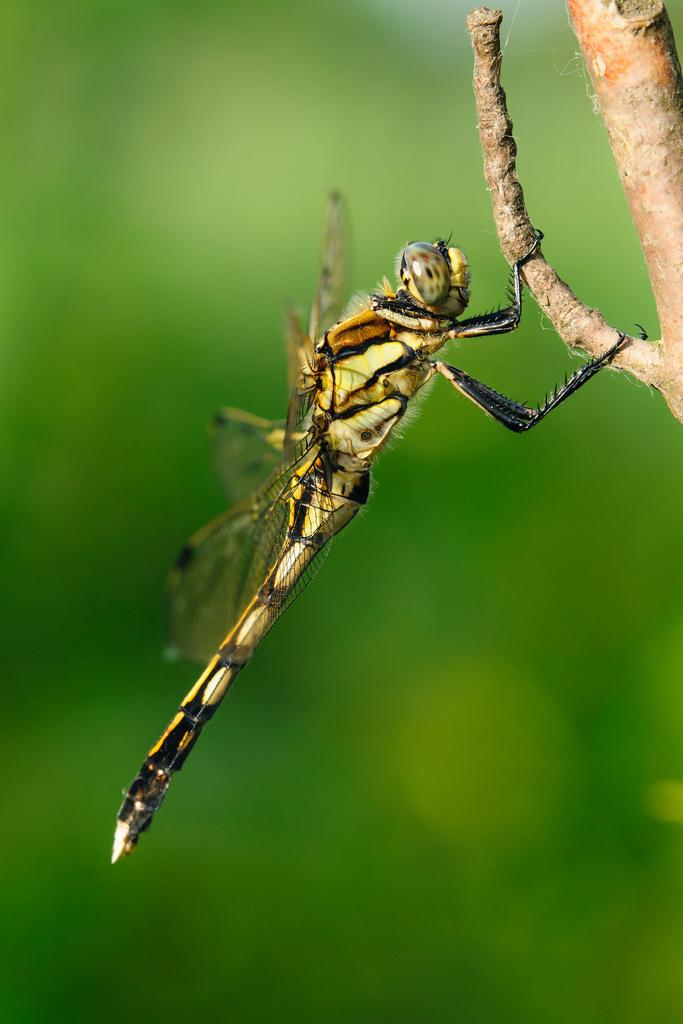What type of creature can be seen in the image? There is an insect in the image. What colors are present on the insect? The insect has yellow and black coloring. Where is the insect located in the image? The insect is on a branch. What color is the background of the image? The background of the image is green. Is there a seat available for the insect in the image? There is no seat present in the image, as it features an insect on a branch. 